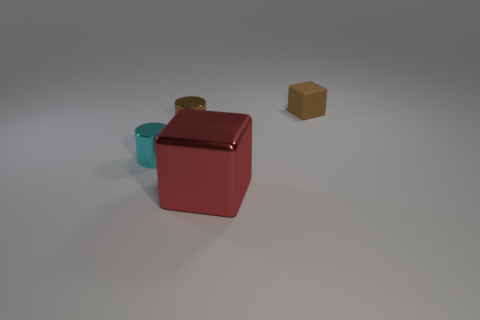Add 2 big green cylinders. How many objects exist? 6 Add 3 small rubber blocks. How many small rubber blocks are left? 4 Add 3 big yellow rubber spheres. How many big yellow rubber spheres exist? 3 Subtract 0 brown spheres. How many objects are left? 4 Subtract all small things. Subtract all big red metallic cylinders. How many objects are left? 1 